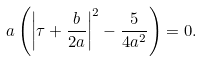<formula> <loc_0><loc_0><loc_500><loc_500>a \left ( \left | \tau + \frac { b } { 2 a } \right | ^ { 2 } - \frac { 5 } { 4 a ^ { 2 } } \right ) = 0 .</formula> 